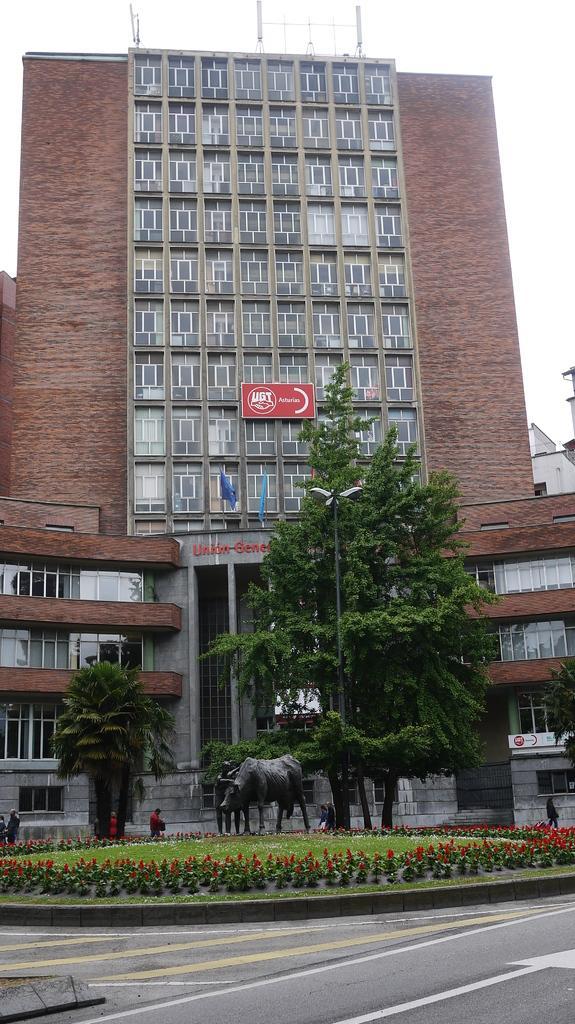Please provide a concise description of this image. In this image I can see a building in brown color, in front I can see trees in green color and a statue, I can also see few flowers in red color. 